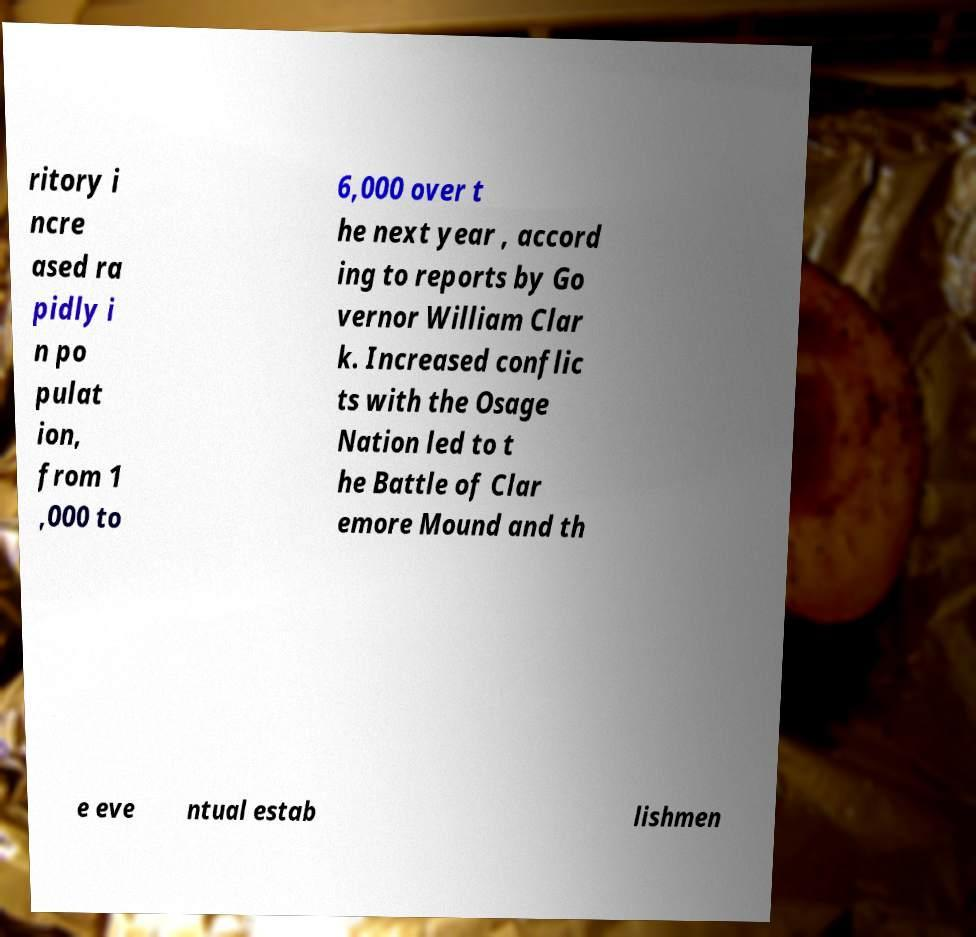Could you assist in decoding the text presented in this image and type it out clearly? ritory i ncre ased ra pidly i n po pulat ion, from 1 ,000 to 6,000 over t he next year , accord ing to reports by Go vernor William Clar k. Increased conflic ts with the Osage Nation led to t he Battle of Clar emore Mound and th e eve ntual estab lishmen 